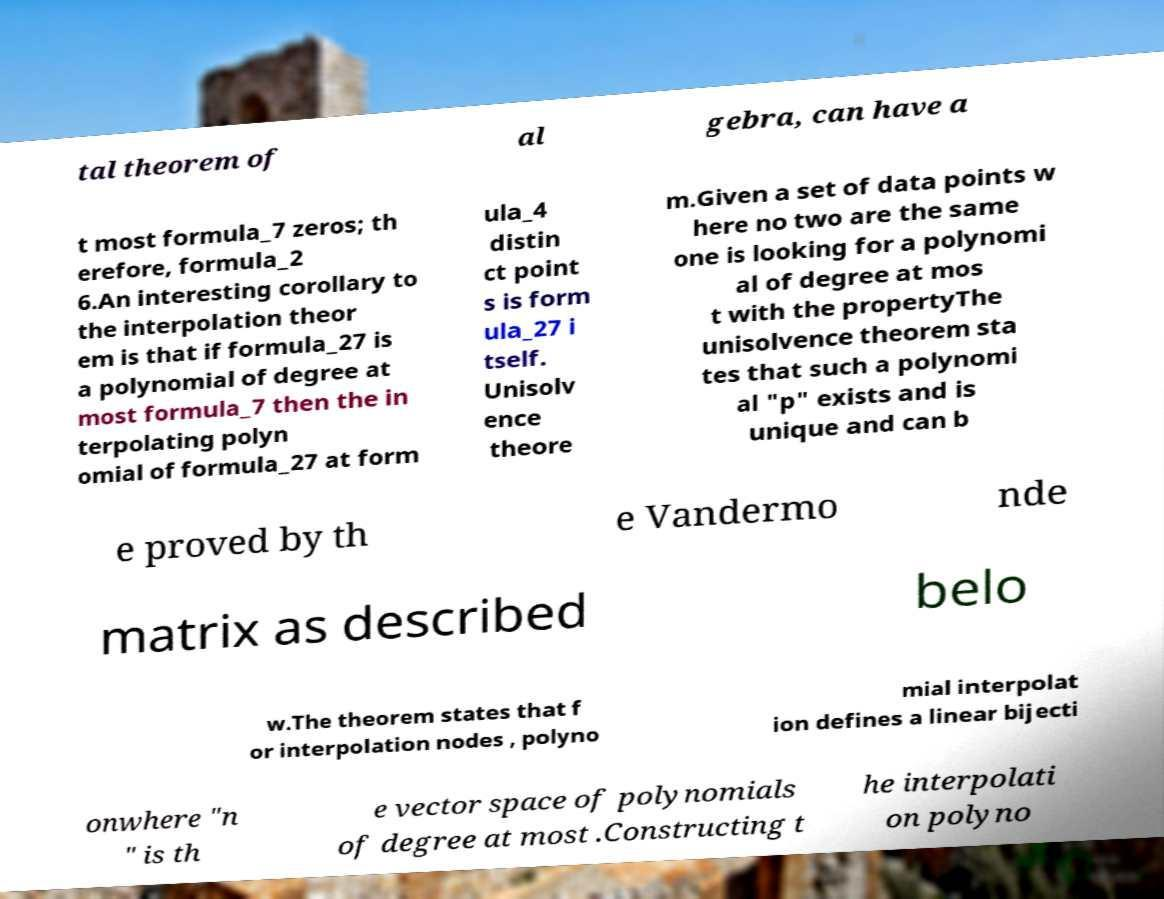Please read and relay the text visible in this image. What does it say? tal theorem of al gebra, can have a t most formula_7 zeros; th erefore, formula_2 6.An interesting corollary to the interpolation theor em is that if formula_27 is a polynomial of degree at most formula_7 then the in terpolating polyn omial of formula_27 at form ula_4 distin ct point s is form ula_27 i tself. Unisolv ence theore m.Given a set of data points w here no two are the same one is looking for a polynomi al of degree at mos t with the propertyThe unisolvence theorem sta tes that such a polynomi al "p" exists and is unique and can b e proved by th e Vandermo nde matrix as described belo w.The theorem states that f or interpolation nodes , polyno mial interpolat ion defines a linear bijecti onwhere "n " is th e vector space of polynomials of degree at most .Constructing t he interpolati on polyno 